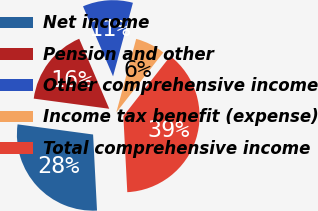<chart> <loc_0><loc_0><loc_500><loc_500><pie_chart><fcel>Net income<fcel>Pension and other<fcel>Other comprehensive income<fcel>Income tax benefit (expense)<fcel>Total comprehensive income<nl><fcel>27.95%<fcel>16.42%<fcel>10.65%<fcel>6.38%<fcel>38.6%<nl></chart> 